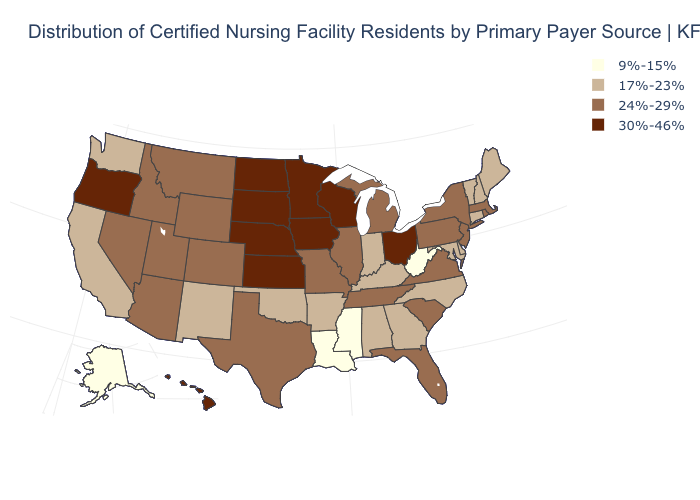Does New Hampshire have the same value as Arkansas?
Concise answer only. Yes. Does the first symbol in the legend represent the smallest category?
Give a very brief answer. Yes. Name the states that have a value in the range 24%-29%?
Be succinct. Arizona, Colorado, Florida, Idaho, Illinois, Massachusetts, Michigan, Missouri, Montana, Nevada, New Jersey, New York, Pennsylvania, Rhode Island, South Carolina, Tennessee, Texas, Utah, Virginia, Wyoming. Name the states that have a value in the range 17%-23%?
Answer briefly. Alabama, Arkansas, California, Connecticut, Delaware, Georgia, Indiana, Kentucky, Maine, Maryland, New Hampshire, New Mexico, North Carolina, Oklahoma, Vermont, Washington. Does South Dakota have the highest value in the USA?
Concise answer only. Yes. Name the states that have a value in the range 30%-46%?
Short answer required. Hawaii, Iowa, Kansas, Minnesota, Nebraska, North Dakota, Ohio, Oregon, South Dakota, Wisconsin. Does Louisiana have the lowest value in the USA?
Short answer required. Yes. Which states hav the highest value in the MidWest?
Answer briefly. Iowa, Kansas, Minnesota, Nebraska, North Dakota, Ohio, South Dakota, Wisconsin. What is the highest value in states that border Nebraska?
Short answer required. 30%-46%. Name the states that have a value in the range 9%-15%?
Short answer required. Alaska, Louisiana, Mississippi, West Virginia. Does the first symbol in the legend represent the smallest category?
Keep it brief. Yes. Name the states that have a value in the range 24%-29%?
Concise answer only. Arizona, Colorado, Florida, Idaho, Illinois, Massachusetts, Michigan, Missouri, Montana, Nevada, New Jersey, New York, Pennsylvania, Rhode Island, South Carolina, Tennessee, Texas, Utah, Virginia, Wyoming. What is the highest value in states that border Alabama?
Quick response, please. 24%-29%. What is the lowest value in the West?
Quick response, please. 9%-15%. What is the highest value in the MidWest ?
Give a very brief answer. 30%-46%. 